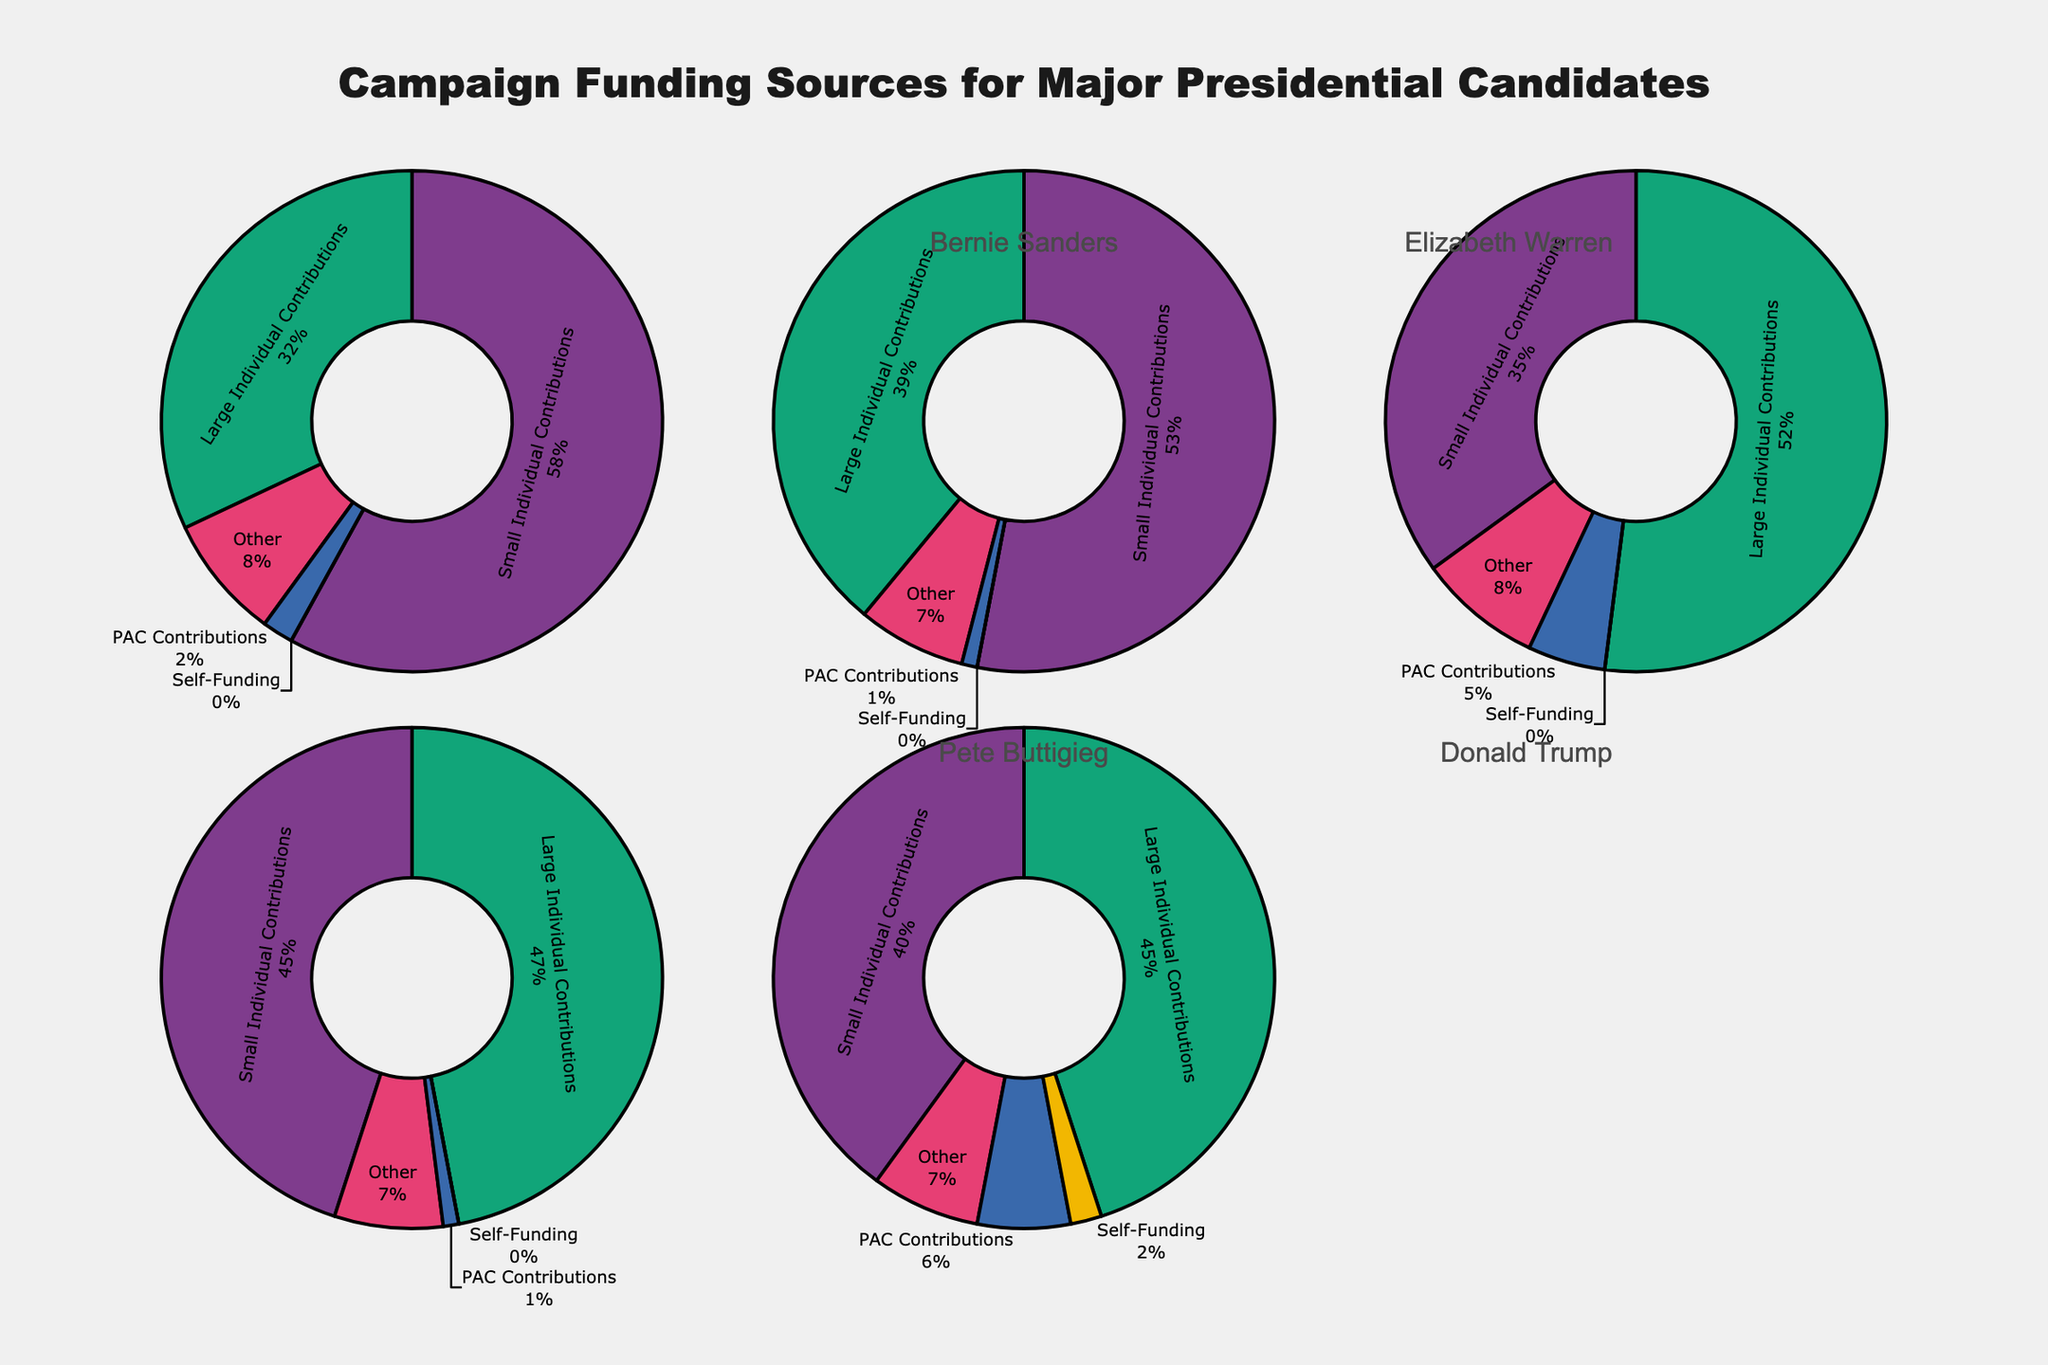Which candidate relies the most on Small Individual Contributions? Bernie Sanders has the largest percentage for Small Individual Contributions at 58%, more than any other candidate.
Answer: Bernie Sanders Who receives the highest percentage of funding from PAC Contributions? Donald Trump receives 6% of his funding from PAC Contributions, which is higher than any other candidate in the dataset.
Answer: Donald Trump Which candidate has the smallest percentage of funding from Large Individual Contributions? Bernie Sanders has the smallest percentage of funding from Large Individual Contributions at 32%.
Answer: Bernie Sanders Compare Joe Biden and Donald Trump in terms of their funding from Small Individual Contributions; who has more? Joe Biden receives 35% from Small Individual Contributions, whereas Donald Trump receives 40%. Therefore, Donald Trump has a higher percentage of small individual contributions compared to Joe Biden.
Answer: Donald Trump What is the total percentage of Self-Funding for all the candidates combined? Bernie Sanders (0%) + Elizabeth Warren (0%) + Joe Biden (0%) + Pete Buttigieg (0%) + Donald Trump (2%) = 2%.
Answer: 2% Among Bernie Sanders and Elizabeth Warren, who has more contributions from Large Individual Contributions and by how much? Bernie Sanders has 32% and Elizabeth Warren has 39% of Large Individual Contributions. The difference is 39% - 32% = 7%.
Answer: Elizabeth Warren, by 7% What is the average percentage of Other contributions across all candidates? Sum of percentages from Other contributions: 8% (Bernie Sanders) + 7% (Elizabeth Warren) + 8% (Joe Biden) + 7% (Pete Buttigieg) + 7% (Donald Trump) = 37%. The average is 37% / 5 = 7.4%.
Answer: 7.4% How many candidates have a higher percentage of Large Individual Contributions than Small Individual Contributions? The candidates who have a higher percentage of Large Individual Contributions than Small Individual Contributions are Joe Biden (52% vs 35%) and Pete Buttigieg (47% vs 45%). There are 2 such candidates.
Answer: 2 What is the difference in percentage of Small Individual Contributions between Elizabeth Warren and Pete Buttigieg? Elizabeth Warren has 53% and Pete Buttigieg has 45% of Small Individual Contributions. The difference is 53% - 45% = 8%.
Answer: 8% Which candidate has the lowest percentage of PAC Contributions, and what is that percentage? Both Bernie Sanders and Elizabeth Warren have the lowest percentage of PAC Contributions at 1%.
Answer: Bernie Sanders and Elizabeth Warren, 1% 